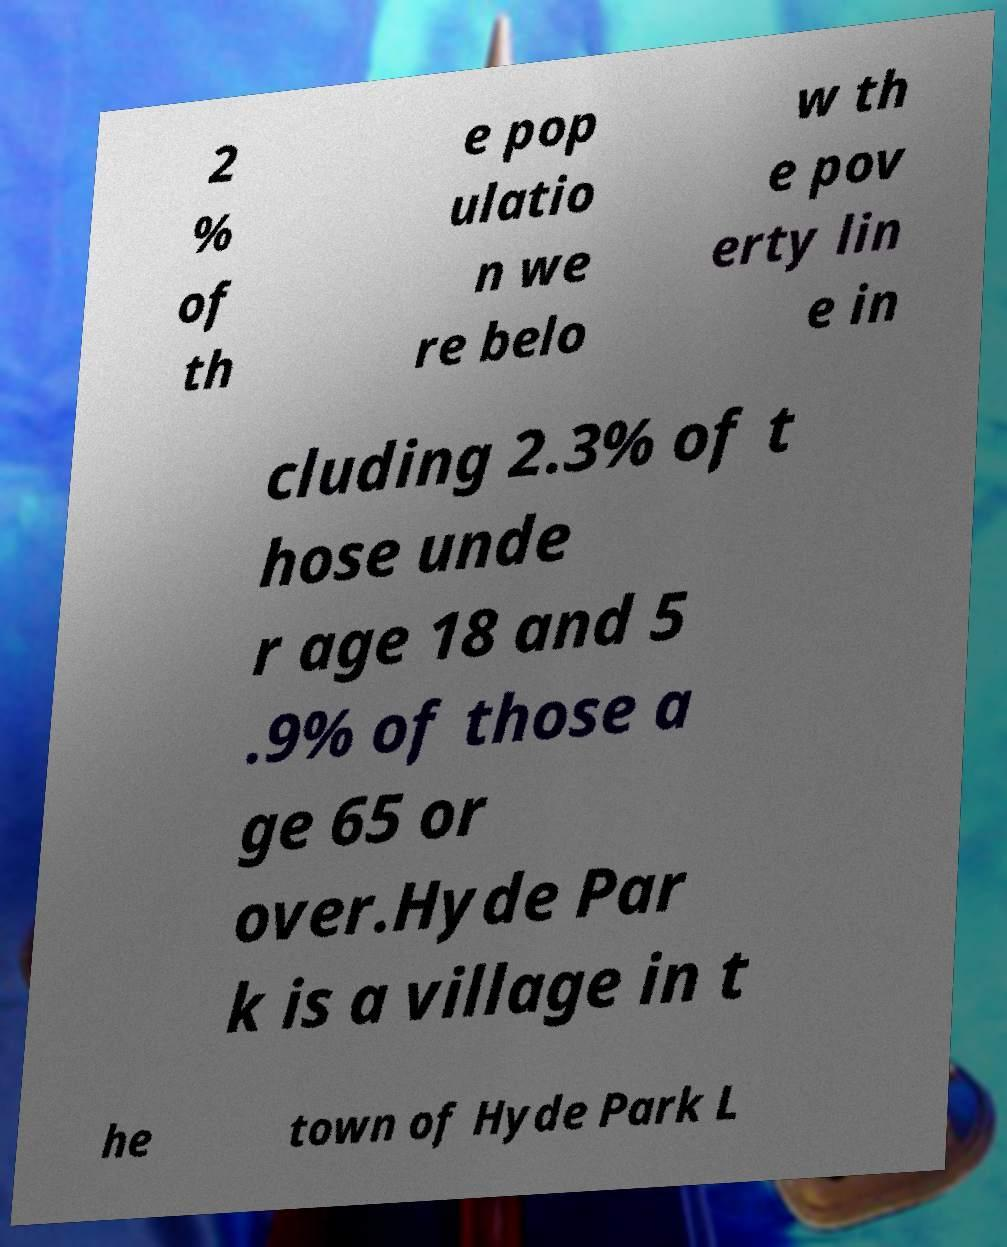There's text embedded in this image that I need extracted. Can you transcribe it verbatim? 2 % of th e pop ulatio n we re belo w th e pov erty lin e in cluding 2.3% of t hose unde r age 18 and 5 .9% of those a ge 65 or over.Hyde Par k is a village in t he town of Hyde Park L 